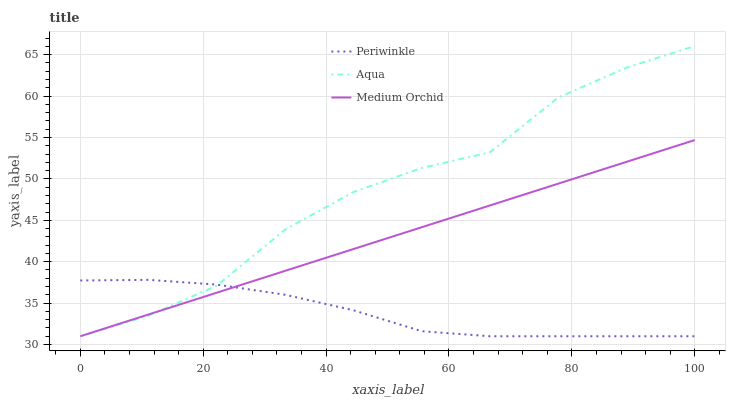Does Periwinkle have the minimum area under the curve?
Answer yes or no. Yes. Does Aqua have the maximum area under the curve?
Answer yes or no. Yes. Does Medium Orchid have the minimum area under the curve?
Answer yes or no. No. Does Medium Orchid have the maximum area under the curve?
Answer yes or no. No. Is Medium Orchid the smoothest?
Answer yes or no. Yes. Is Aqua the roughest?
Answer yes or no. Yes. Is Periwinkle the smoothest?
Answer yes or no. No. Is Periwinkle the roughest?
Answer yes or no. No. Does Aqua have the lowest value?
Answer yes or no. Yes. Does Aqua have the highest value?
Answer yes or no. Yes. Does Medium Orchid have the highest value?
Answer yes or no. No. Does Periwinkle intersect Medium Orchid?
Answer yes or no. Yes. Is Periwinkle less than Medium Orchid?
Answer yes or no. No. Is Periwinkle greater than Medium Orchid?
Answer yes or no. No. 